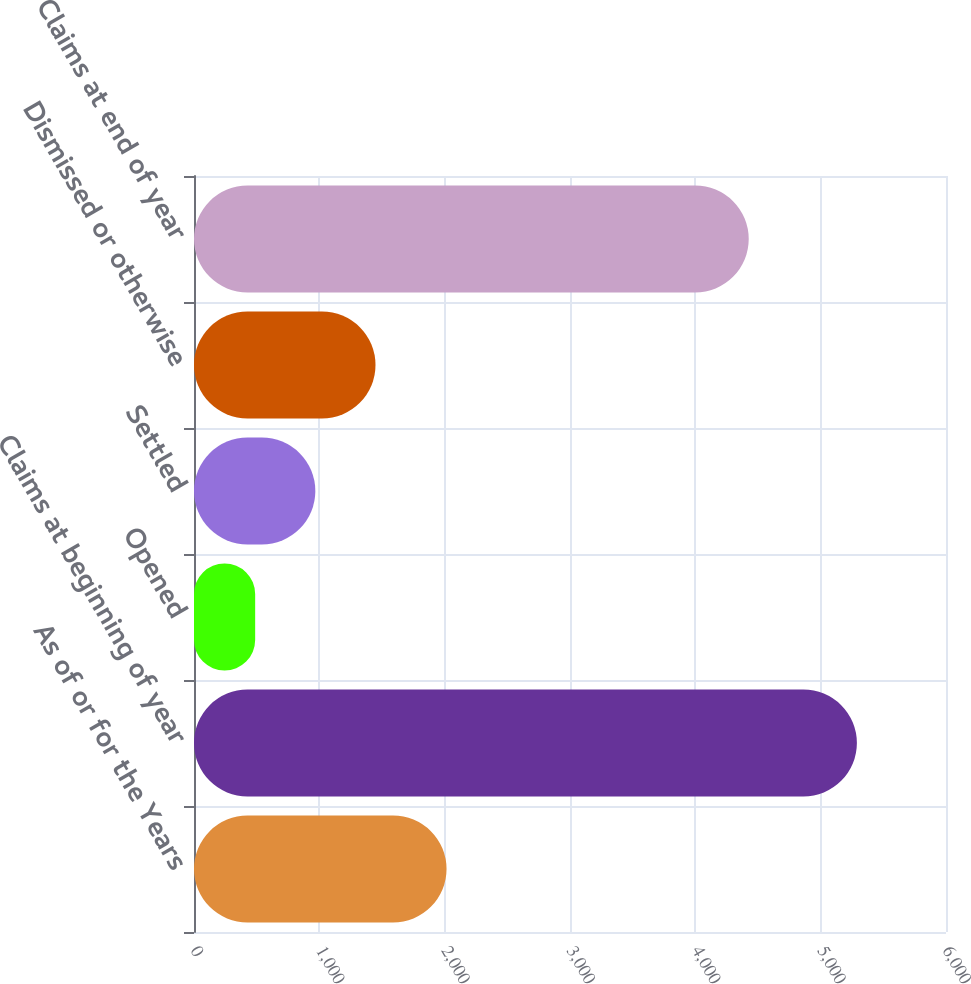<chart> <loc_0><loc_0><loc_500><loc_500><bar_chart><fcel>As of or for the Years<fcel>Claims at beginning of year<fcel>Opened<fcel>Settled<fcel>Dismissed or otherwise<fcel>Claims at end of year<nl><fcel>2015<fcel>5289<fcel>488<fcel>968.1<fcel>1448.2<fcel>4426<nl></chart> 